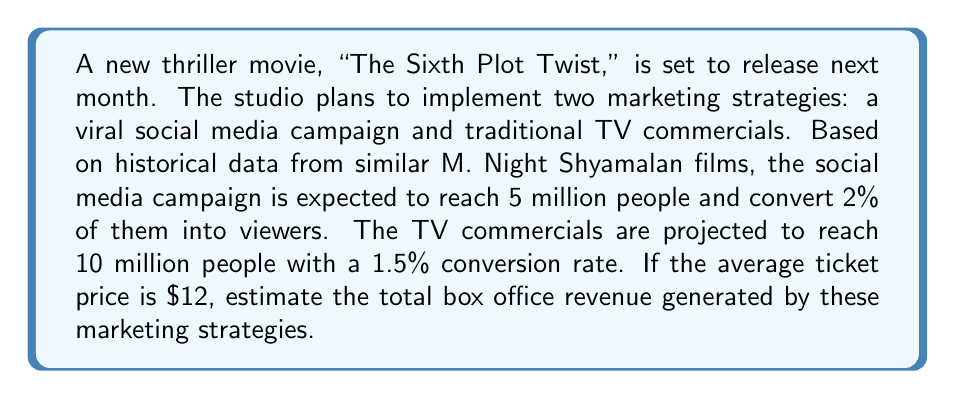Could you help me with this problem? Let's break this down step-by-step:

1. Calculate the number of viewers from the social media campaign:
   $$ V_{social} = 5,000,000 \times 0.02 = 100,000 \text{ viewers} $$

2. Calculate the number of viewers from TV commercials:
   $$ V_{TV} = 10,000,000 \times 0.015 = 150,000 \text{ viewers} $$

3. Calculate the total number of viewers:
   $$ V_{total} = V_{social} + V_{TV} = 100,000 + 150,000 = 250,000 \text{ viewers} $$

4. Calculate the total box office revenue:
   $$ R = V_{total} \times \text{Ticket Price} $$
   $$ R = 250,000 \times \$12 = \$3,000,000 $$

Therefore, the estimated box office revenue generated by these marketing strategies is $3,000,000.
Answer: $3,000,000 